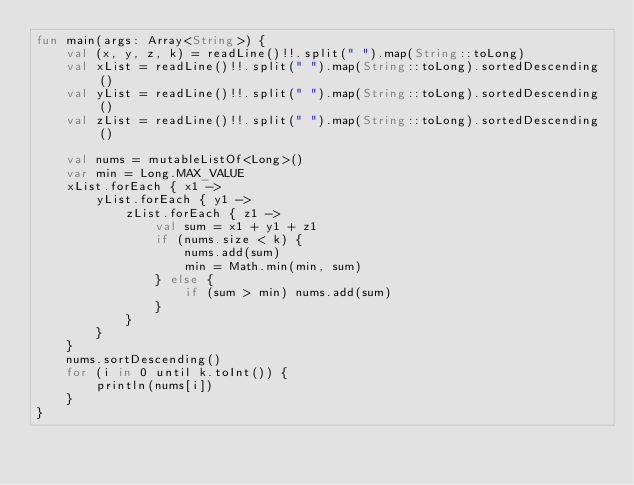Convert code to text. <code><loc_0><loc_0><loc_500><loc_500><_Kotlin_>fun main(args: Array<String>) {
    val (x, y, z, k) = readLine()!!.split(" ").map(String::toLong)
    val xList = readLine()!!.split(" ").map(String::toLong).sortedDescending()
    val yList = readLine()!!.split(" ").map(String::toLong).sortedDescending()
    val zList = readLine()!!.split(" ").map(String::toLong).sortedDescending()

    val nums = mutableListOf<Long>()
    var min = Long.MAX_VALUE
    xList.forEach { x1 ->
        yList.forEach { y1 ->
            zList.forEach { z1 ->
                val sum = x1 + y1 + z1
                if (nums.size < k) {
                    nums.add(sum)
                    min = Math.min(min, sum)
                } else {
                    if (sum > min) nums.add(sum)
                }
            }
        }
    }
    nums.sortDescending()
    for (i in 0 until k.toInt()) {
        println(nums[i])
    }
}</code> 